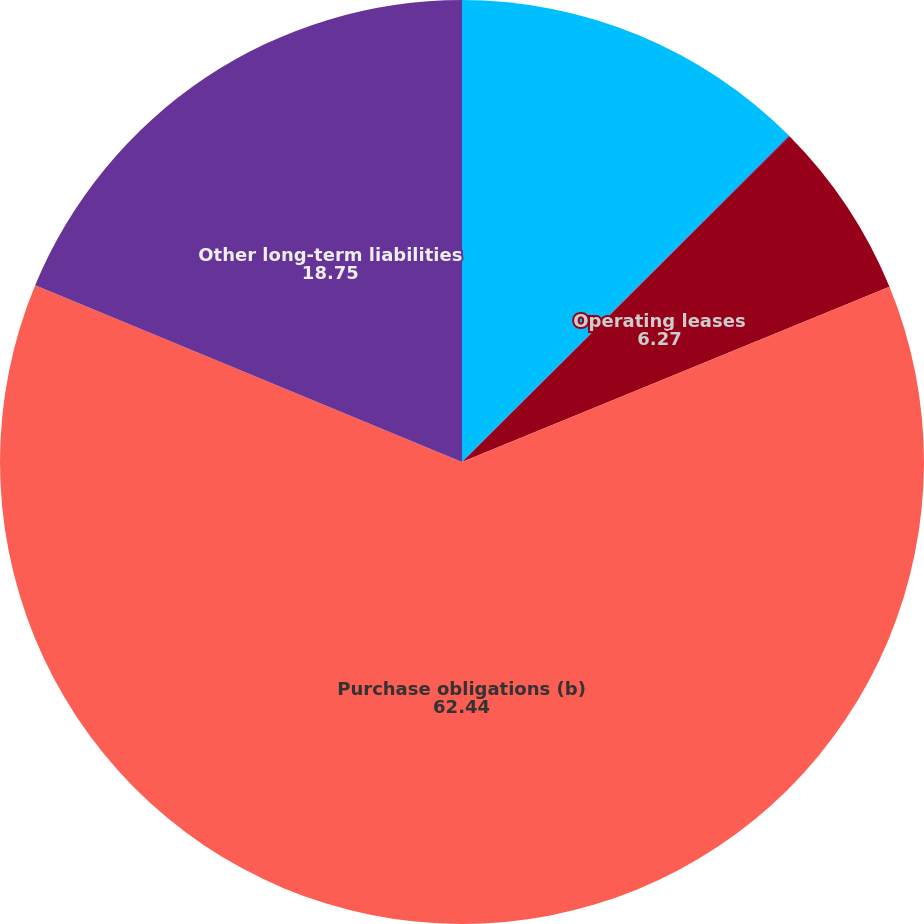Convert chart to OTSL. <chart><loc_0><loc_0><loc_500><loc_500><pie_chart><fcel>Long-term debt (a)<fcel>Capital lease obligations<fcel>Operating leases<fcel>Purchase obligations (b)<fcel>Other long-term liabilities<nl><fcel>12.51%<fcel>0.03%<fcel>6.27%<fcel>62.44%<fcel>18.75%<nl></chart> 